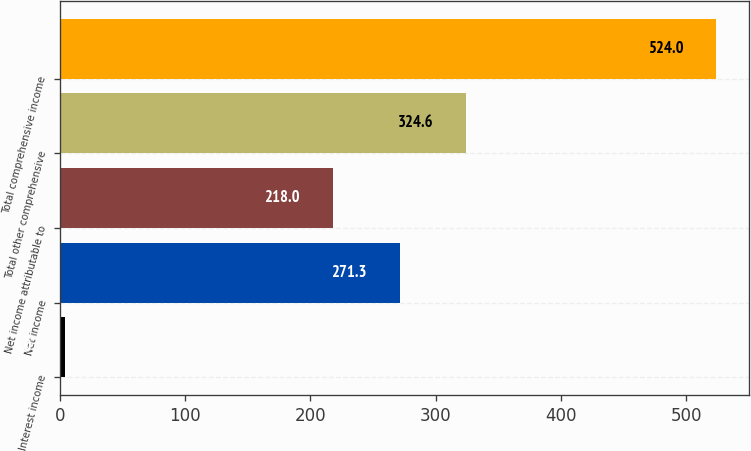Convert chart. <chart><loc_0><loc_0><loc_500><loc_500><bar_chart><fcel>Interest income<fcel>Net income<fcel>Net income attributable to<fcel>Total other comprehensive<fcel>Total comprehensive income<nl><fcel>4<fcel>271.3<fcel>218<fcel>324.6<fcel>524<nl></chart> 